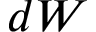<formula> <loc_0><loc_0><loc_500><loc_500>d W</formula> 